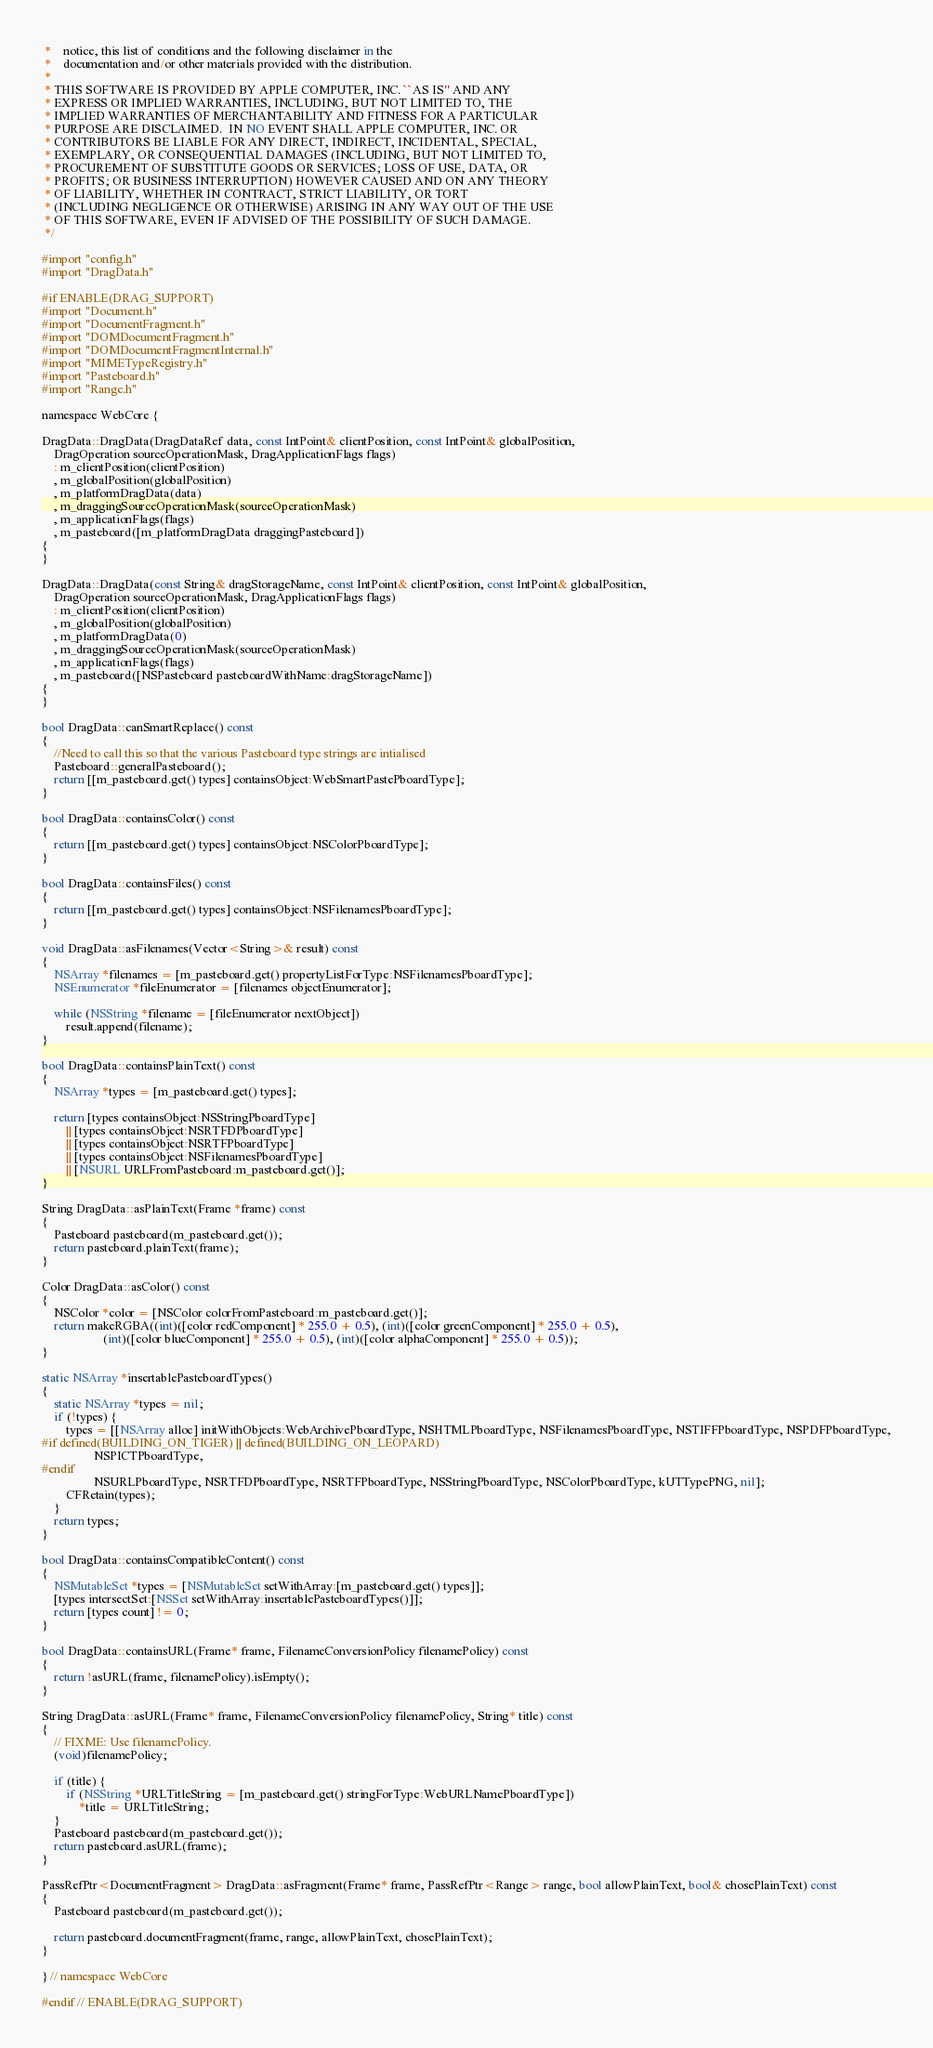Convert code to text. <code><loc_0><loc_0><loc_500><loc_500><_ObjectiveC_> *    notice, this list of conditions and the following disclaimer in the
 *    documentation and/or other materials provided with the distribution.
 *
 * THIS SOFTWARE IS PROVIDED BY APPLE COMPUTER, INC. ``AS IS'' AND ANY
 * EXPRESS OR IMPLIED WARRANTIES, INCLUDING, BUT NOT LIMITED TO, THE
 * IMPLIED WARRANTIES OF MERCHANTABILITY AND FITNESS FOR A PARTICULAR
 * PURPOSE ARE DISCLAIMED.  IN NO EVENT SHALL APPLE COMPUTER, INC. OR
 * CONTRIBUTORS BE LIABLE FOR ANY DIRECT, INDIRECT, INCIDENTAL, SPECIAL,
 * EXEMPLARY, OR CONSEQUENTIAL DAMAGES (INCLUDING, BUT NOT LIMITED TO,
 * PROCUREMENT OF SUBSTITUTE GOODS OR SERVICES; LOSS OF USE, DATA, OR
 * PROFITS; OR BUSINESS INTERRUPTION) HOWEVER CAUSED AND ON ANY THEORY
 * OF LIABILITY, WHETHER IN CONTRACT, STRICT LIABILITY, OR TORT
 * (INCLUDING NEGLIGENCE OR OTHERWISE) ARISING IN ANY WAY OUT OF THE USE
 * OF THIS SOFTWARE, EVEN IF ADVISED OF THE POSSIBILITY OF SUCH DAMAGE. 
 */

#import "config.h"
#import "DragData.h"

#if ENABLE(DRAG_SUPPORT)
#import "Document.h"
#import "DocumentFragment.h"
#import "DOMDocumentFragment.h"
#import "DOMDocumentFragmentInternal.h"
#import "MIMETypeRegistry.h"
#import "Pasteboard.h"
#import "Range.h"

namespace WebCore {

DragData::DragData(DragDataRef data, const IntPoint& clientPosition, const IntPoint& globalPosition, 
    DragOperation sourceOperationMask, DragApplicationFlags flags)
    : m_clientPosition(clientPosition)
    , m_globalPosition(globalPosition)
    , m_platformDragData(data)
    , m_draggingSourceOperationMask(sourceOperationMask)
    , m_applicationFlags(flags)
    , m_pasteboard([m_platformDragData draggingPasteboard])
{
}

DragData::DragData(const String& dragStorageName, const IntPoint& clientPosition, const IntPoint& globalPosition,
    DragOperation sourceOperationMask, DragApplicationFlags flags)
    : m_clientPosition(clientPosition)
    , m_globalPosition(globalPosition)
    , m_platformDragData(0)
    , m_draggingSourceOperationMask(sourceOperationMask)
    , m_applicationFlags(flags)
    , m_pasteboard([NSPasteboard pasteboardWithName:dragStorageName])
{
}
    
bool DragData::canSmartReplace() const
{
    //Need to call this so that the various Pasteboard type strings are intialised
    Pasteboard::generalPasteboard();
    return [[m_pasteboard.get() types] containsObject:WebSmartPastePboardType];
}

bool DragData::containsColor() const
{
    return [[m_pasteboard.get() types] containsObject:NSColorPboardType];
}

bool DragData::containsFiles() const
{
    return [[m_pasteboard.get() types] containsObject:NSFilenamesPboardType];
}

void DragData::asFilenames(Vector<String>& result) const
{
    NSArray *filenames = [m_pasteboard.get() propertyListForType:NSFilenamesPboardType];
    NSEnumerator *fileEnumerator = [filenames objectEnumerator];
    
    while (NSString *filename = [fileEnumerator nextObject])
        result.append(filename);
}

bool DragData::containsPlainText() const
{
    NSArray *types = [m_pasteboard.get() types];
    
    return [types containsObject:NSStringPboardType] 
        || [types containsObject:NSRTFDPboardType]
        || [types containsObject:NSRTFPboardType]
        || [types containsObject:NSFilenamesPboardType]
        || [NSURL URLFromPasteboard:m_pasteboard.get()];
}

String DragData::asPlainText(Frame *frame) const
{
    Pasteboard pasteboard(m_pasteboard.get());
    return pasteboard.plainText(frame);
}

Color DragData::asColor() const
{
    NSColor *color = [NSColor colorFromPasteboard:m_pasteboard.get()];
    return makeRGBA((int)([color redComponent] * 255.0 + 0.5), (int)([color greenComponent] * 255.0 + 0.5), 
                    (int)([color blueComponent] * 255.0 + 0.5), (int)([color alphaComponent] * 255.0 + 0.5));
}

static NSArray *insertablePasteboardTypes()
{
    static NSArray *types = nil;
    if (!types) {
        types = [[NSArray alloc] initWithObjects:WebArchivePboardType, NSHTMLPboardType, NSFilenamesPboardType, NSTIFFPboardType, NSPDFPboardType,
#if defined(BUILDING_ON_TIGER) || defined(BUILDING_ON_LEOPARD)
                 NSPICTPboardType,
#endif
                 NSURLPboardType, NSRTFDPboardType, NSRTFPboardType, NSStringPboardType, NSColorPboardType, kUTTypePNG, nil];
        CFRetain(types);
    }
    return types;
}
    
bool DragData::containsCompatibleContent() const
{
    NSMutableSet *types = [NSMutableSet setWithArray:[m_pasteboard.get() types]];
    [types intersectSet:[NSSet setWithArray:insertablePasteboardTypes()]];
    return [types count] != 0;
}
    
bool DragData::containsURL(Frame* frame, FilenameConversionPolicy filenamePolicy) const
{
    return !asURL(frame, filenamePolicy).isEmpty();
}
    
String DragData::asURL(Frame* frame, FilenameConversionPolicy filenamePolicy, String* title) const
{
    // FIXME: Use filenamePolicy.
    (void)filenamePolicy;

    if (title) {
        if (NSString *URLTitleString = [m_pasteboard.get() stringForType:WebURLNamePboardType])
            *title = URLTitleString;
    }
    Pasteboard pasteboard(m_pasteboard.get());
    return pasteboard.asURL(frame);
}

PassRefPtr<DocumentFragment> DragData::asFragment(Frame* frame, PassRefPtr<Range> range, bool allowPlainText, bool& chosePlainText) const
{
    Pasteboard pasteboard(m_pasteboard.get());
    
    return pasteboard.documentFragment(frame, range, allowPlainText, chosePlainText);
}
    
} // namespace WebCore

#endif // ENABLE(DRAG_SUPPORT)
</code> 